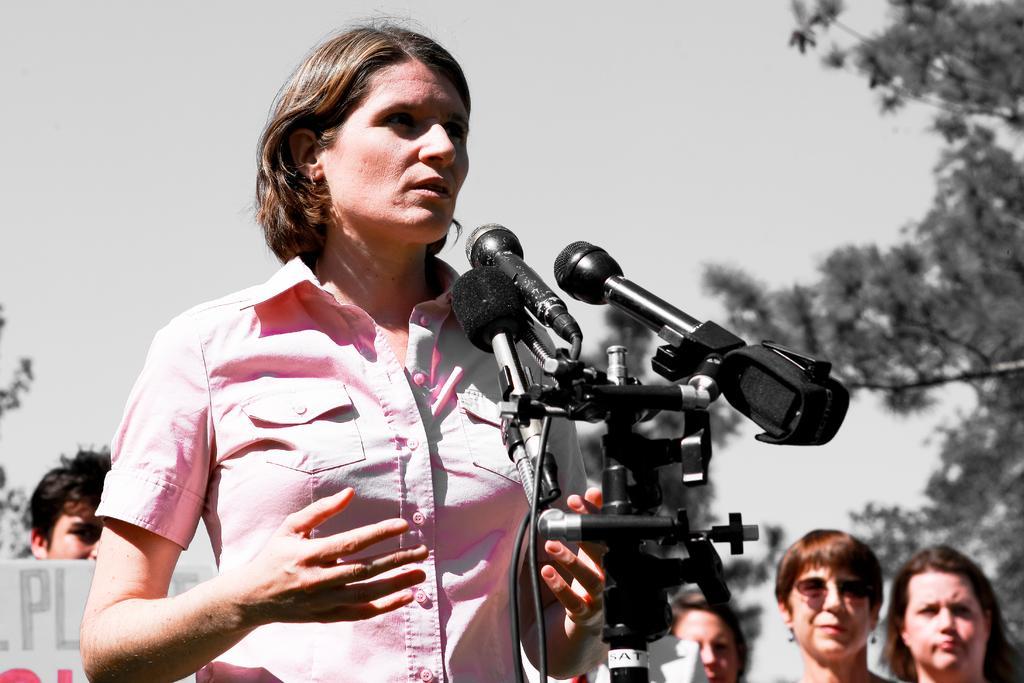Describe this image in one or two sentences. In this image I can see the person standing in front of few microphones. In the background I can see group of people standing and I can also see few trees and the sky is in white color. 